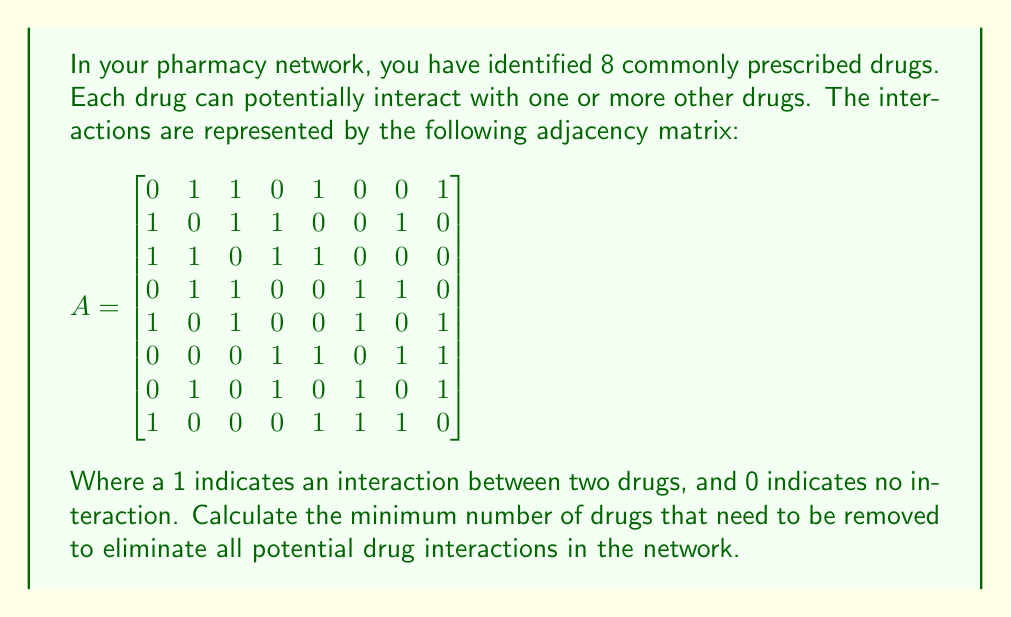Could you help me with this problem? To solve this problem, we need to find the minimum vertex cover of the graph represented by the adjacency matrix. The minimum vertex cover is the smallest set of vertices (drugs) that, when removed, eliminates all edges (interactions) in the graph.

Step 1: Understand the graph structure
- We have 8 vertices (drugs) in the graph.
- Each edge represents an interaction between two drugs.

Step 2: Analyze the graph
- This is a complex graph with multiple interconnections.
- Finding the exact minimum vertex cover for larger graphs is an NP-hard problem.

Step 3: Use a greedy approximation algorithm
We'll use a simple greedy algorithm to approximate the minimum vertex cover:
1. Select the vertex with the highest degree (most connections).
2. Remove this vertex and all its edges from the graph.
3. Repeat until no edges remain.

Step 4: Apply the algorithm
1. Initial degrees: [4, 4, 4, 4, 4, 4, 4, 4]
2. Remove vertex 2 (0-indexed): [3, 3, 3, 3, 3, 3, 3]
3. Remove vertex 0: [2, 2, 2, 2, 2, 2]
4. Remove vertex 4: [1, 1, 1, 1, 1]
5. Remove vertex 7: [0, 0, 0, 0]

Step 5: Count removed vertices
We removed 4 vertices (drugs) to eliminate all interactions.

Note: This greedy approach may not always yield the optimal solution, but it provides a good approximation for complex graphs.
Answer: 4 